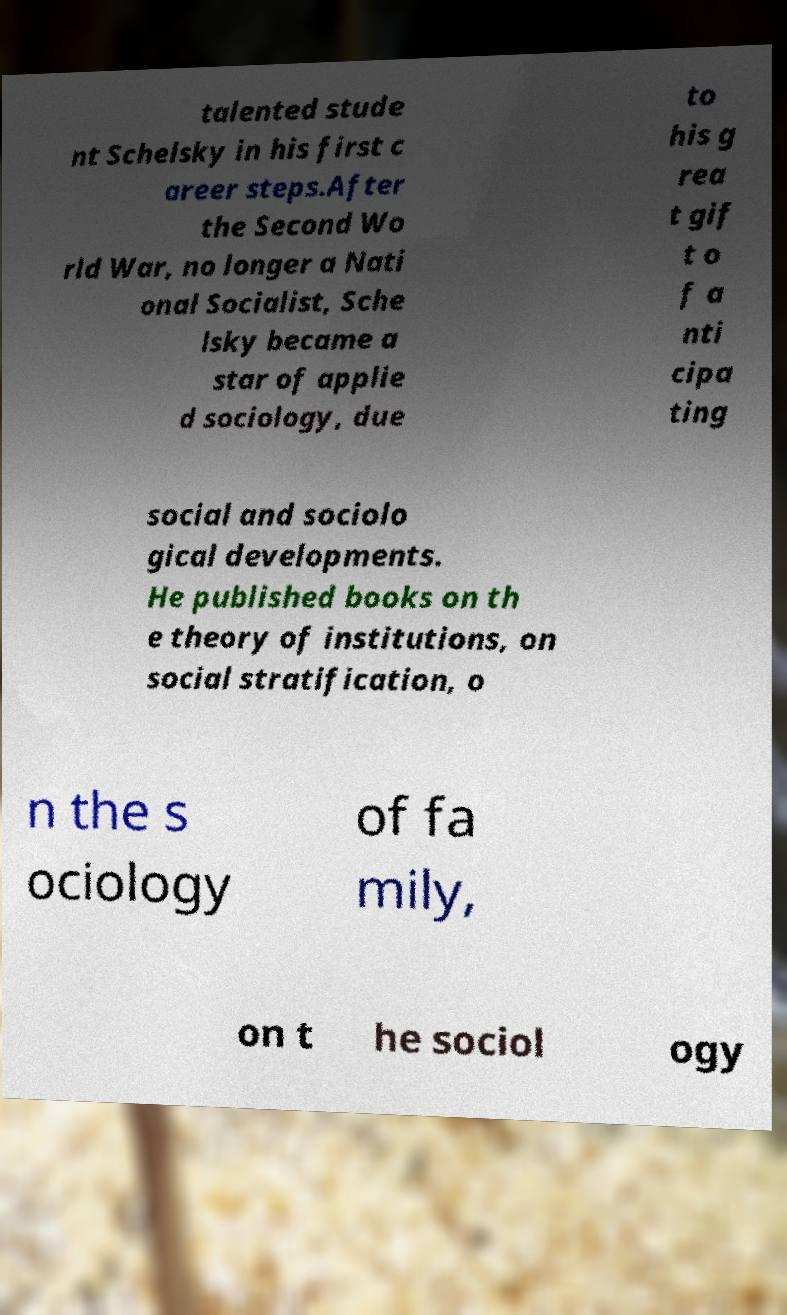Could you extract and type out the text from this image? talented stude nt Schelsky in his first c areer steps.After the Second Wo rld War, no longer a Nati onal Socialist, Sche lsky became a star of applie d sociology, due to his g rea t gif t o f a nti cipa ting social and sociolo gical developments. He published books on th e theory of institutions, on social stratification, o n the s ociology of fa mily, on t he sociol ogy 